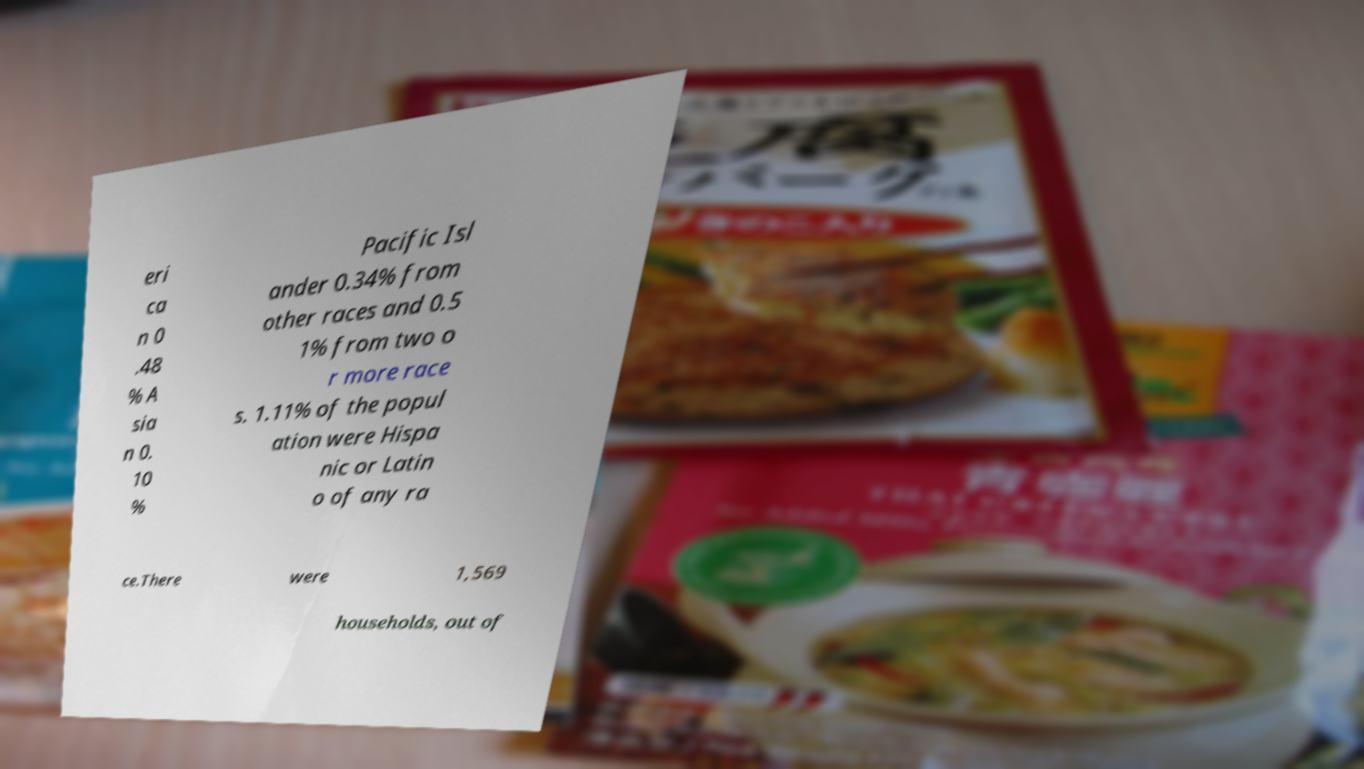Can you read and provide the text displayed in the image?This photo seems to have some interesting text. Can you extract and type it out for me? eri ca n 0 .48 % A sia n 0. 10 % Pacific Isl ander 0.34% from other races and 0.5 1% from two o r more race s. 1.11% of the popul ation were Hispa nic or Latin o of any ra ce.There were 1,569 households, out of 